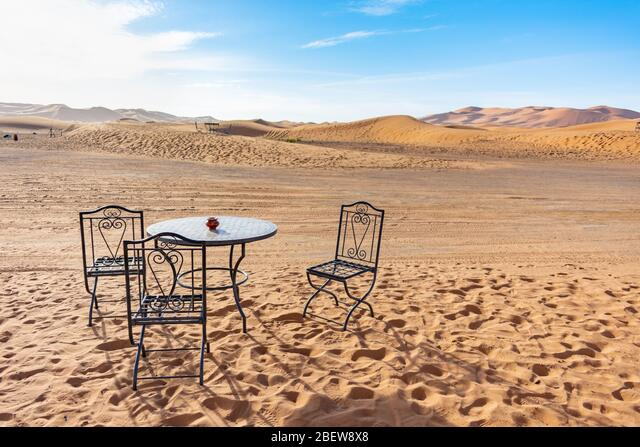How many chairs are there in the image? 3 